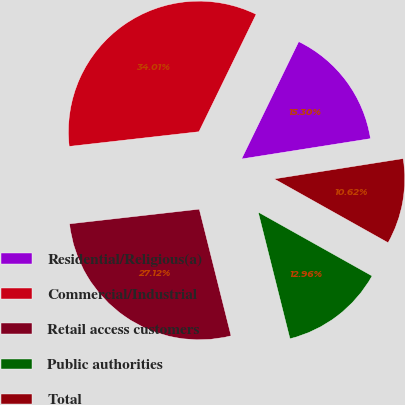Convert chart. <chart><loc_0><loc_0><loc_500><loc_500><pie_chart><fcel>Residential/Religious(a)<fcel>Commercial/Industrial<fcel>Retail access customers<fcel>Public authorities<fcel>Total<nl><fcel>15.3%<fcel>34.01%<fcel>27.12%<fcel>12.96%<fcel>10.62%<nl></chart> 